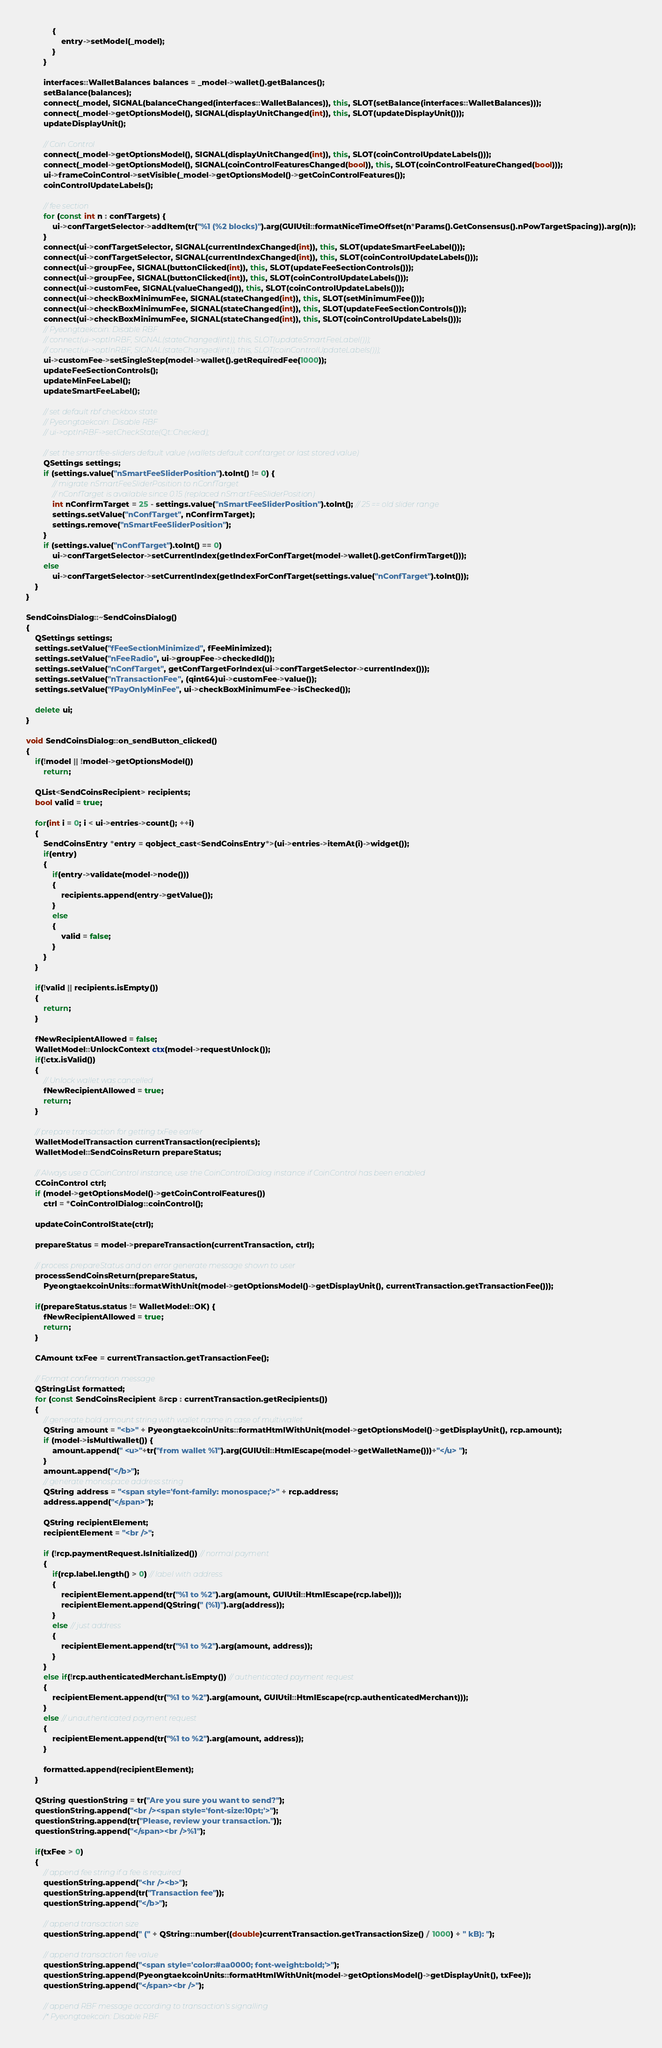Convert code to text. <code><loc_0><loc_0><loc_500><loc_500><_C++_>            {
                entry->setModel(_model);
            }
        }

        interfaces::WalletBalances balances = _model->wallet().getBalances();
        setBalance(balances);
        connect(_model, SIGNAL(balanceChanged(interfaces::WalletBalances)), this, SLOT(setBalance(interfaces::WalletBalances)));
        connect(_model->getOptionsModel(), SIGNAL(displayUnitChanged(int)), this, SLOT(updateDisplayUnit()));
        updateDisplayUnit();

        // Coin Control
        connect(_model->getOptionsModel(), SIGNAL(displayUnitChanged(int)), this, SLOT(coinControlUpdateLabels()));
        connect(_model->getOptionsModel(), SIGNAL(coinControlFeaturesChanged(bool)), this, SLOT(coinControlFeatureChanged(bool)));
        ui->frameCoinControl->setVisible(_model->getOptionsModel()->getCoinControlFeatures());
        coinControlUpdateLabels();

        // fee section
        for (const int n : confTargets) {
            ui->confTargetSelector->addItem(tr("%1 (%2 blocks)").arg(GUIUtil::formatNiceTimeOffset(n*Params().GetConsensus().nPowTargetSpacing)).arg(n));
        }
        connect(ui->confTargetSelector, SIGNAL(currentIndexChanged(int)), this, SLOT(updateSmartFeeLabel()));
        connect(ui->confTargetSelector, SIGNAL(currentIndexChanged(int)), this, SLOT(coinControlUpdateLabels()));
        connect(ui->groupFee, SIGNAL(buttonClicked(int)), this, SLOT(updateFeeSectionControls()));
        connect(ui->groupFee, SIGNAL(buttonClicked(int)), this, SLOT(coinControlUpdateLabels()));
        connect(ui->customFee, SIGNAL(valueChanged()), this, SLOT(coinControlUpdateLabels()));
        connect(ui->checkBoxMinimumFee, SIGNAL(stateChanged(int)), this, SLOT(setMinimumFee()));
        connect(ui->checkBoxMinimumFee, SIGNAL(stateChanged(int)), this, SLOT(updateFeeSectionControls()));
        connect(ui->checkBoxMinimumFee, SIGNAL(stateChanged(int)), this, SLOT(coinControlUpdateLabels()));
        // Pyeongtaekcoin: Disable RBF
        // connect(ui->optInRBF, SIGNAL(stateChanged(int)), this, SLOT(updateSmartFeeLabel()));
        // connect(ui->optInRBF, SIGNAL(stateChanged(int)), this, SLOT(coinControlUpdateLabels()));
        ui->customFee->setSingleStep(model->wallet().getRequiredFee(1000));
        updateFeeSectionControls();
        updateMinFeeLabel();
        updateSmartFeeLabel();

        // set default rbf checkbox state
        // Pyeongtaekcoin: Disable RBF
        // ui->optInRBF->setCheckState(Qt::Checked);

        // set the smartfee-sliders default value (wallets default conf.target or last stored value)
        QSettings settings;
        if (settings.value("nSmartFeeSliderPosition").toInt() != 0) {
            // migrate nSmartFeeSliderPosition to nConfTarget
            // nConfTarget is available since 0.15 (replaced nSmartFeeSliderPosition)
            int nConfirmTarget = 25 - settings.value("nSmartFeeSliderPosition").toInt(); // 25 == old slider range
            settings.setValue("nConfTarget", nConfirmTarget);
            settings.remove("nSmartFeeSliderPosition");
        }
        if (settings.value("nConfTarget").toInt() == 0)
            ui->confTargetSelector->setCurrentIndex(getIndexForConfTarget(model->wallet().getConfirmTarget()));
        else
            ui->confTargetSelector->setCurrentIndex(getIndexForConfTarget(settings.value("nConfTarget").toInt()));
    }
}

SendCoinsDialog::~SendCoinsDialog()
{
    QSettings settings;
    settings.setValue("fFeeSectionMinimized", fFeeMinimized);
    settings.setValue("nFeeRadio", ui->groupFee->checkedId());
    settings.setValue("nConfTarget", getConfTargetForIndex(ui->confTargetSelector->currentIndex()));
    settings.setValue("nTransactionFee", (qint64)ui->customFee->value());
    settings.setValue("fPayOnlyMinFee", ui->checkBoxMinimumFee->isChecked());

    delete ui;
}

void SendCoinsDialog::on_sendButton_clicked()
{
    if(!model || !model->getOptionsModel())
        return;

    QList<SendCoinsRecipient> recipients;
    bool valid = true;

    for(int i = 0; i < ui->entries->count(); ++i)
    {
        SendCoinsEntry *entry = qobject_cast<SendCoinsEntry*>(ui->entries->itemAt(i)->widget());
        if(entry)
        {
            if(entry->validate(model->node()))
            {
                recipients.append(entry->getValue());
            }
            else
            {
                valid = false;
            }
        }
    }

    if(!valid || recipients.isEmpty())
    {
        return;
    }

    fNewRecipientAllowed = false;
    WalletModel::UnlockContext ctx(model->requestUnlock());
    if(!ctx.isValid())
    {
        // Unlock wallet was cancelled
        fNewRecipientAllowed = true;
        return;
    }

    // prepare transaction for getting txFee earlier
    WalletModelTransaction currentTransaction(recipients);
    WalletModel::SendCoinsReturn prepareStatus;

    // Always use a CCoinControl instance, use the CoinControlDialog instance if CoinControl has been enabled
    CCoinControl ctrl;
    if (model->getOptionsModel()->getCoinControlFeatures())
        ctrl = *CoinControlDialog::coinControl();

    updateCoinControlState(ctrl);

    prepareStatus = model->prepareTransaction(currentTransaction, ctrl);

    // process prepareStatus and on error generate message shown to user
    processSendCoinsReturn(prepareStatus,
        PyeongtaekcoinUnits::formatWithUnit(model->getOptionsModel()->getDisplayUnit(), currentTransaction.getTransactionFee()));

    if(prepareStatus.status != WalletModel::OK) {
        fNewRecipientAllowed = true;
        return;
    }

    CAmount txFee = currentTransaction.getTransactionFee();

    // Format confirmation message
    QStringList formatted;
    for (const SendCoinsRecipient &rcp : currentTransaction.getRecipients())
    {
        // generate bold amount string with wallet name in case of multiwallet
        QString amount = "<b>" + PyeongtaekcoinUnits::formatHtmlWithUnit(model->getOptionsModel()->getDisplayUnit(), rcp.amount);
        if (model->isMultiwallet()) {
            amount.append(" <u>"+tr("from wallet %1").arg(GUIUtil::HtmlEscape(model->getWalletName()))+"</u> ");
        }
        amount.append("</b>");
        // generate monospace address string
        QString address = "<span style='font-family: monospace;'>" + rcp.address;
        address.append("</span>");

        QString recipientElement;
        recipientElement = "<br />";

        if (!rcp.paymentRequest.IsInitialized()) // normal payment
        {
            if(rcp.label.length() > 0) // label with address
            {
                recipientElement.append(tr("%1 to %2").arg(amount, GUIUtil::HtmlEscape(rcp.label)));
                recipientElement.append(QString(" (%1)").arg(address));
            }
            else // just address
            {
                recipientElement.append(tr("%1 to %2").arg(amount, address));
            }
        }
        else if(!rcp.authenticatedMerchant.isEmpty()) // authenticated payment request
        {
            recipientElement.append(tr("%1 to %2").arg(amount, GUIUtil::HtmlEscape(rcp.authenticatedMerchant)));
        }
        else // unauthenticated payment request
        {
            recipientElement.append(tr("%1 to %2").arg(amount, address));
        }

        formatted.append(recipientElement);
    }

    QString questionString = tr("Are you sure you want to send?");
    questionString.append("<br /><span style='font-size:10pt;'>");
    questionString.append(tr("Please, review your transaction."));
    questionString.append("</span><br />%1");

    if(txFee > 0)
    {
        // append fee string if a fee is required
        questionString.append("<hr /><b>");
        questionString.append(tr("Transaction fee"));
        questionString.append("</b>");

        // append transaction size
        questionString.append(" (" + QString::number((double)currentTransaction.getTransactionSize() / 1000) + " kB): ");

        // append transaction fee value
        questionString.append("<span style='color:#aa0000; font-weight:bold;'>");
        questionString.append(PyeongtaekcoinUnits::formatHtmlWithUnit(model->getOptionsModel()->getDisplayUnit(), txFee));
        questionString.append("</span><br />");

        // append RBF message according to transaction's signalling
        /* Pyeongtaekcoin: Disable RBF</code> 